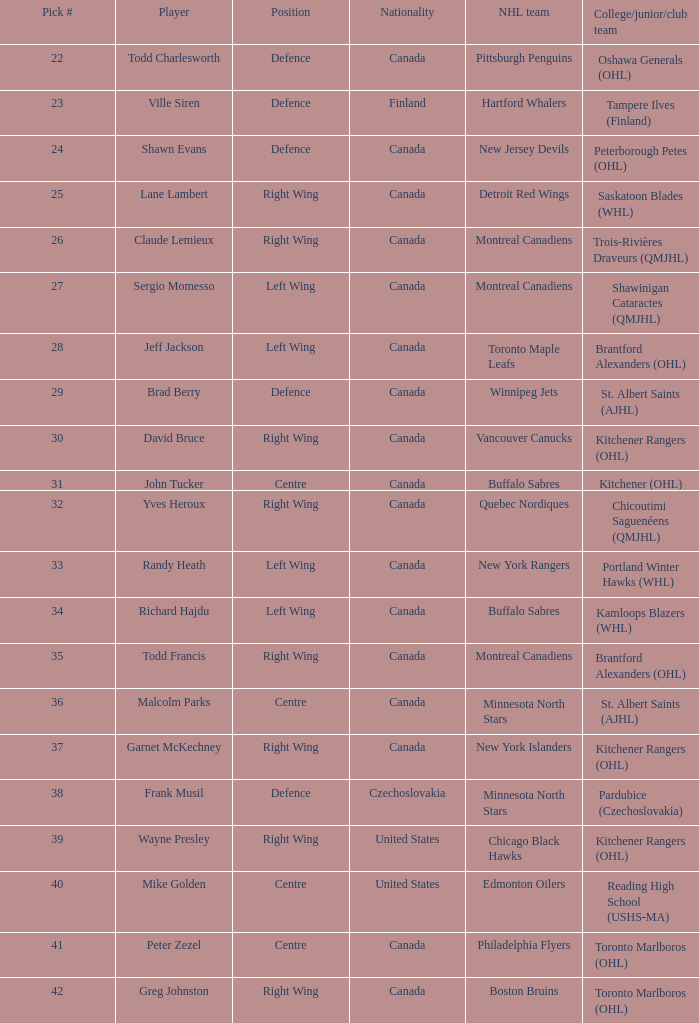Where do the toronto maple leafs stand in the nhl? Left Wing. 